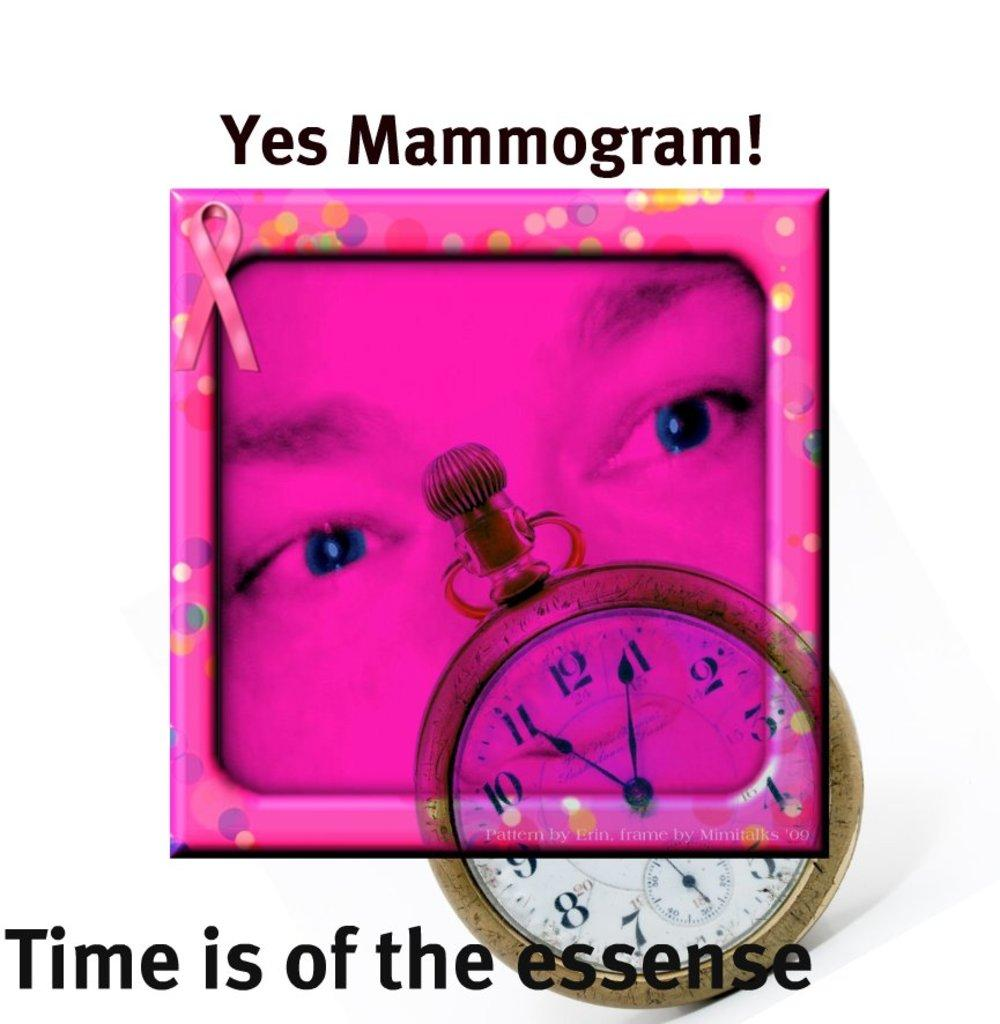<image>
Describe the image concisely. an ad for mammograms says that it is now time to do it 